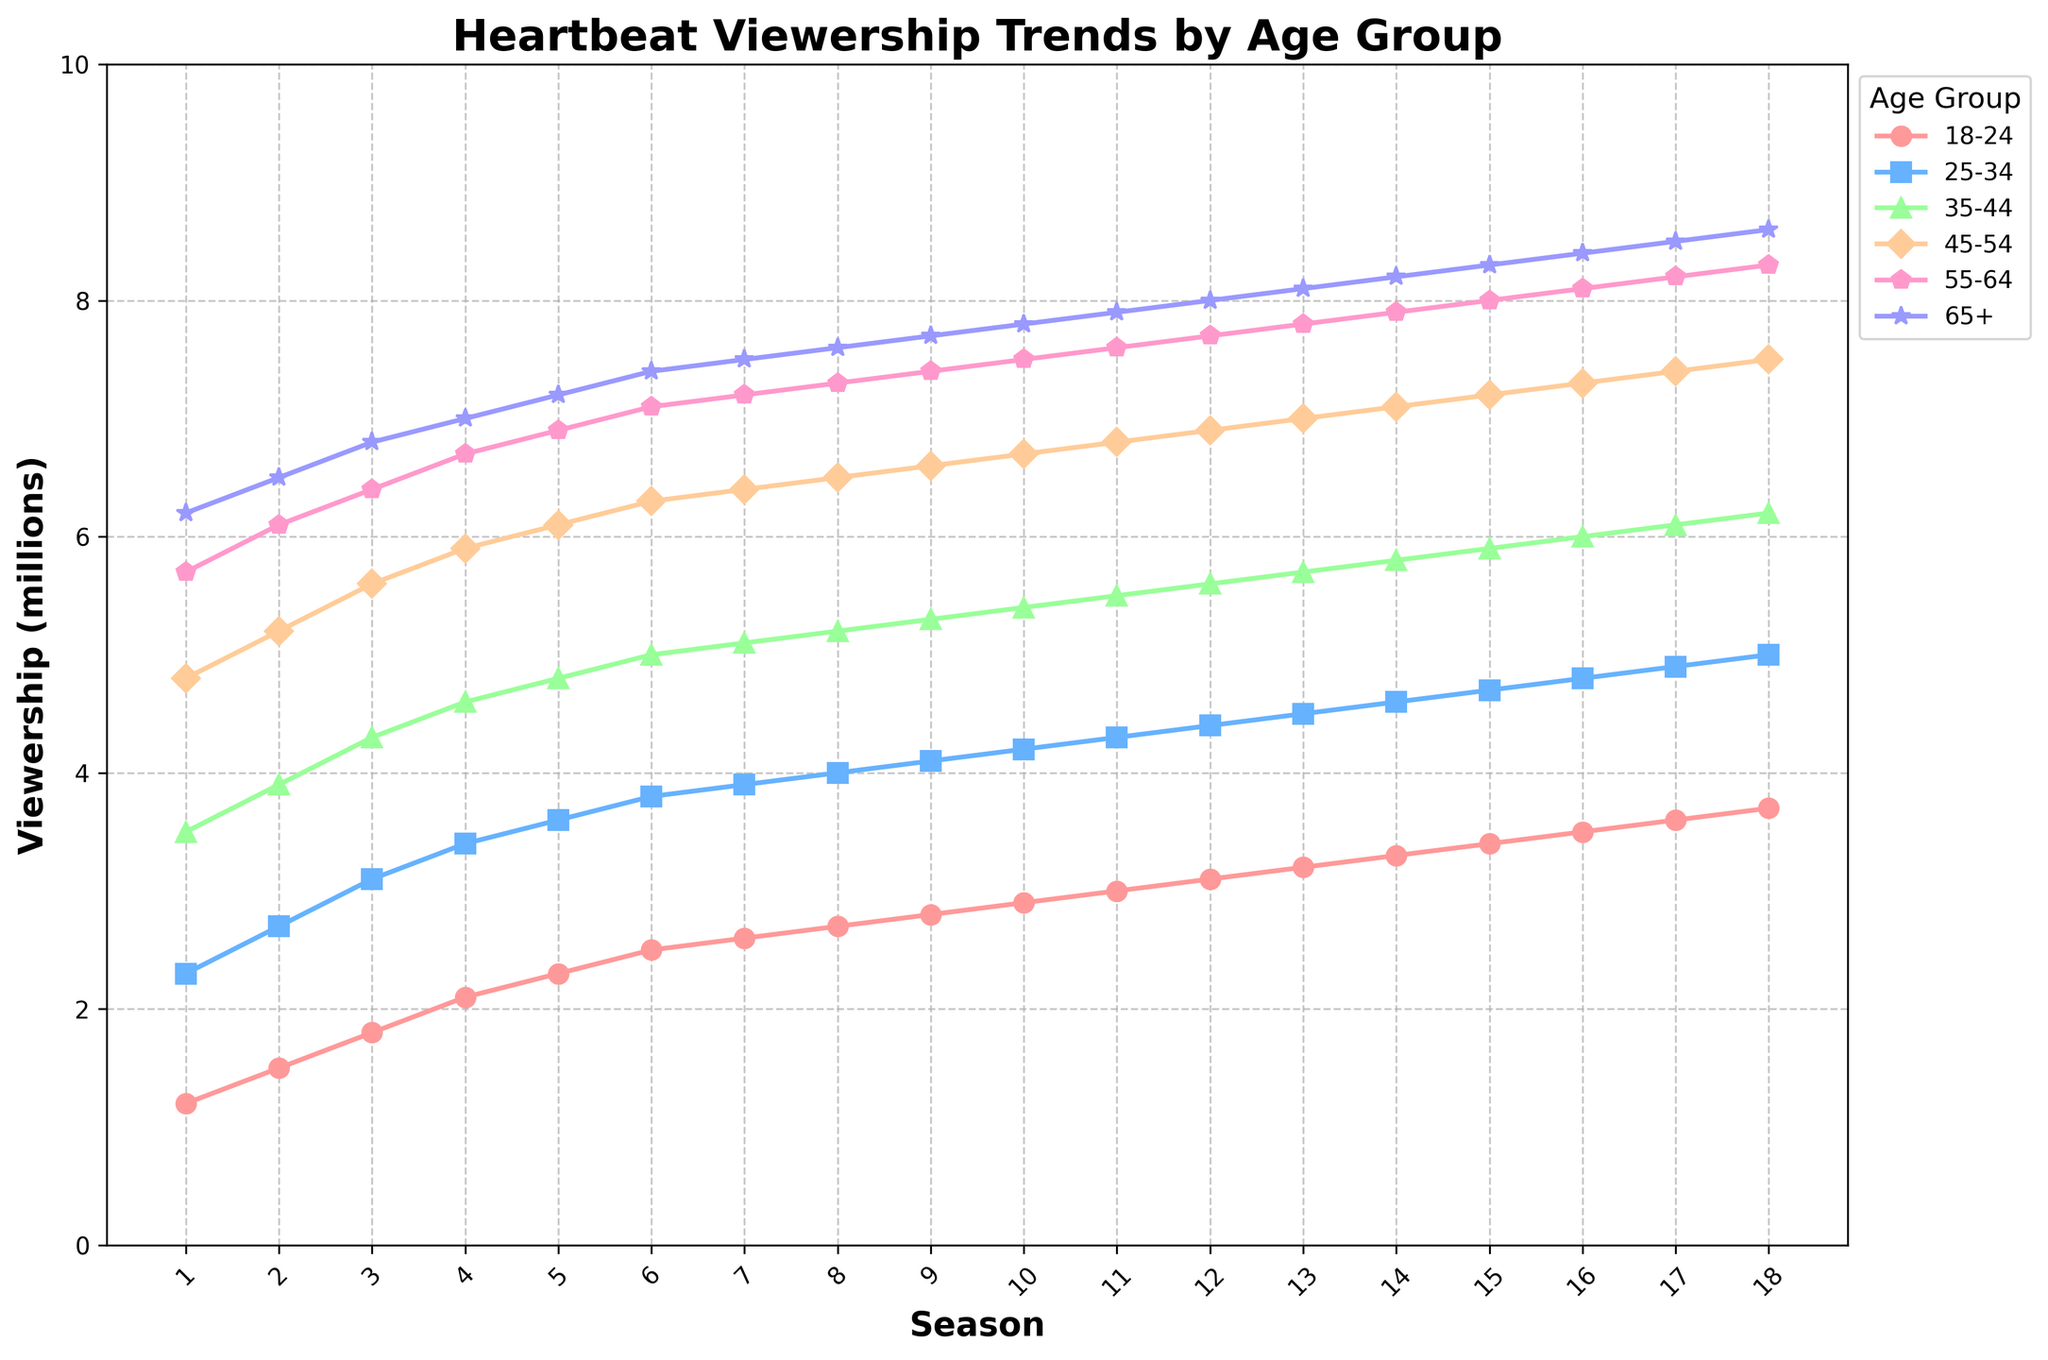What's the overall trend in viewership across all age groups from Season 1 to Season 18? Looking at the lines representing each age group's viewership, we can see that all lines generally trend upwards from left to right across the seasons, indicating an overall increase in viewership across all age groups.
Answer: Increasing Which age group had the highest viewership in Season 10? By identifying which line reaches the highest point at the Season 10 marker on the x-axis, we can see that the line for the 65+ age group is the highest.
Answer: 65+ How does the viewership of the 25-34 age group in Season 18 compare to that in Season 1? The viewership for the 25-34 age group in Season 1 is 2.3 million, and in Season 18 it is 5.0 million. Subtracting the initial value from the final value, 5.0 - 2.3, we find an increase of 2.7 million.
Answer: Increased by 2.7 million By how much did the viewership in the 35-44 age group increase from Season 5 to Season 13? The viewership for the 35-44 age group in Season 5 is 4.8 million, and in Season 13 it is 5.7 million. Subtracting the initial value from the final value, 5.7 - 4.8, shows an increase of 0.9 million.
Answer: Increased by 0.9 million Which season experienced the highest increase in viewership for the 45-54 age group compared to the previous season? The 45-54 viewership shows the steepest increase between Season 15 and Season 16, where it goes from 7.2 to 7.3 million, an increase of 0.1 million, compared to smaller increases in other seasons.
Answer: Season 16 What is the average viewership of the 18-24 age group across all seasons? Summing the viewership figures for all 18 seasons, (1.2 + 1.5 + 1.8 + 2.1 + 2.3 + 2.5 + 2.6 + 2.7 + 2.8 + 2.9 + 3.0 + 3.1 + 3.2 + 3.3 + 3.4 + 3.5 + 3.6 + 3.7) = 55.5. Then dividing by the number of seasons, 55.5 / 18, gives an average viewership of ~3.08 million.
Answer: ~3.08 million Are there any age groups whose viewership grew at a consistent rate throughout all 18 seasons? The viewership lines for age groups 65+ and 55-64 show consistent, steady increases with no sudden jumps or drops, indicating a consistent growth rate.
Answer: 65+ and 55-64 Which two age groups have the smallest difference in viewership in Season 12? At Season 12, the viewership of the 18-24 group is 3.1 million and the 25-34 group is 4.4 million, with a difference of 1.3 million. Comparing other pairs, no other pairs have a smaller difference, so these two age groups have the smallest difference.
Answer: 18-24 and 25-34 By how much does the average viewership of the 45-54 age group exceed that of the 35-44 age group? Summing the viewership figures for 45-54 (4.8 + 5.2 + 5.6 + 5.9 + 6.1 + 6.3 + 6.4 + 6.5 + 6.6 + 6.7 + 6.8 + 6.9 + 7.0 + 7.1 + 7.2 + 7.3 + 7.4 + 7.5 = 115.3) and dividing by 18 gives ~6.4 million average. For 35-44, (3.5 + 3.9 + 4.3 + 4.6 + 4.8 + 5.0 + 5.1 + 5.2 + 5.3 + 5.4 + 5.5 + 5.6 + 5.7 + 5.8 + 5.9 + 6.0 + 6.1 + 6.2 = 95.5), giving ~5.3 million average. The difference is ~6.4 - ~5.3 = 1.1 million.
Answer: ~1.1 million 